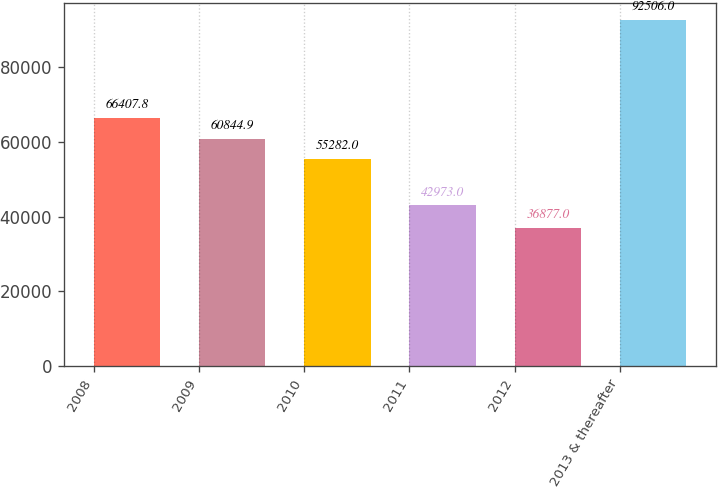Convert chart. <chart><loc_0><loc_0><loc_500><loc_500><bar_chart><fcel>2008<fcel>2009<fcel>2010<fcel>2011<fcel>2012<fcel>2013 & thereafter<nl><fcel>66407.8<fcel>60844.9<fcel>55282<fcel>42973<fcel>36877<fcel>92506<nl></chart> 